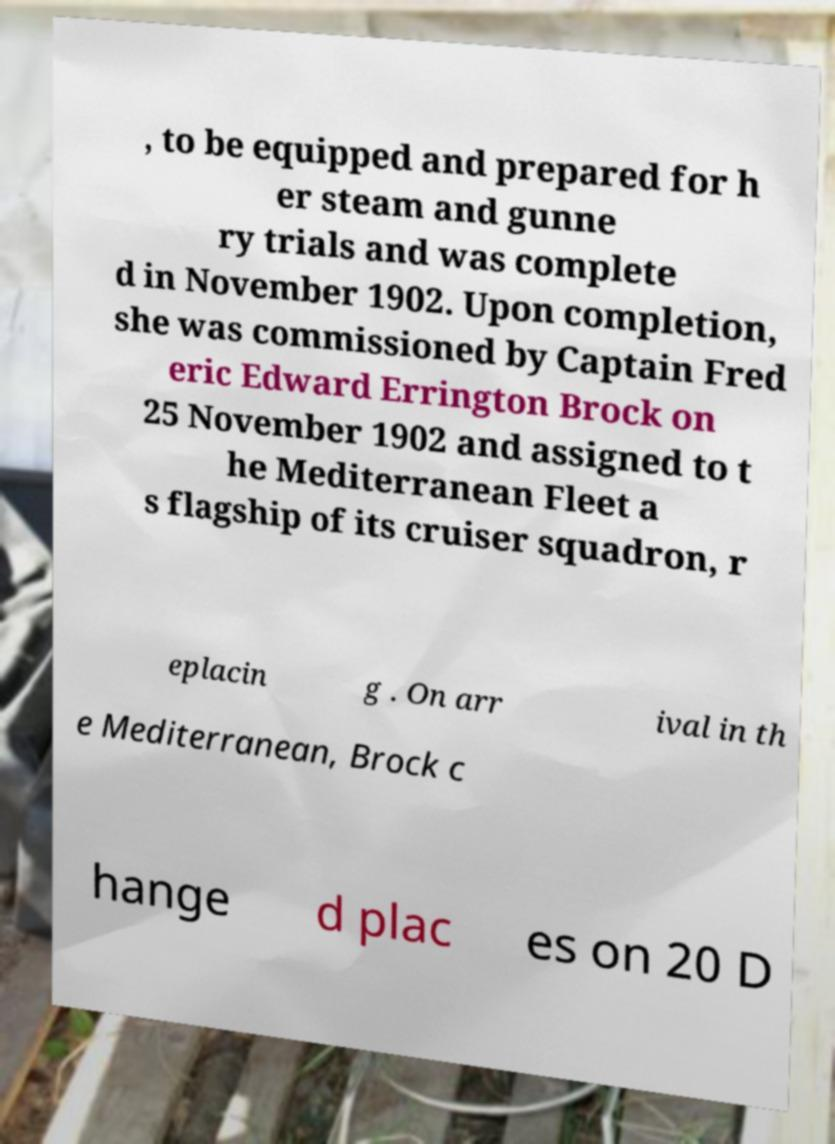Can you read and provide the text displayed in the image?This photo seems to have some interesting text. Can you extract and type it out for me? , to be equipped and prepared for h er steam and gunne ry trials and was complete d in November 1902. Upon completion, she was commissioned by Captain Fred eric Edward Errington Brock on 25 November 1902 and assigned to t he Mediterranean Fleet a s flagship of its cruiser squadron, r eplacin g . On arr ival in th e Mediterranean, Brock c hange d plac es on 20 D 